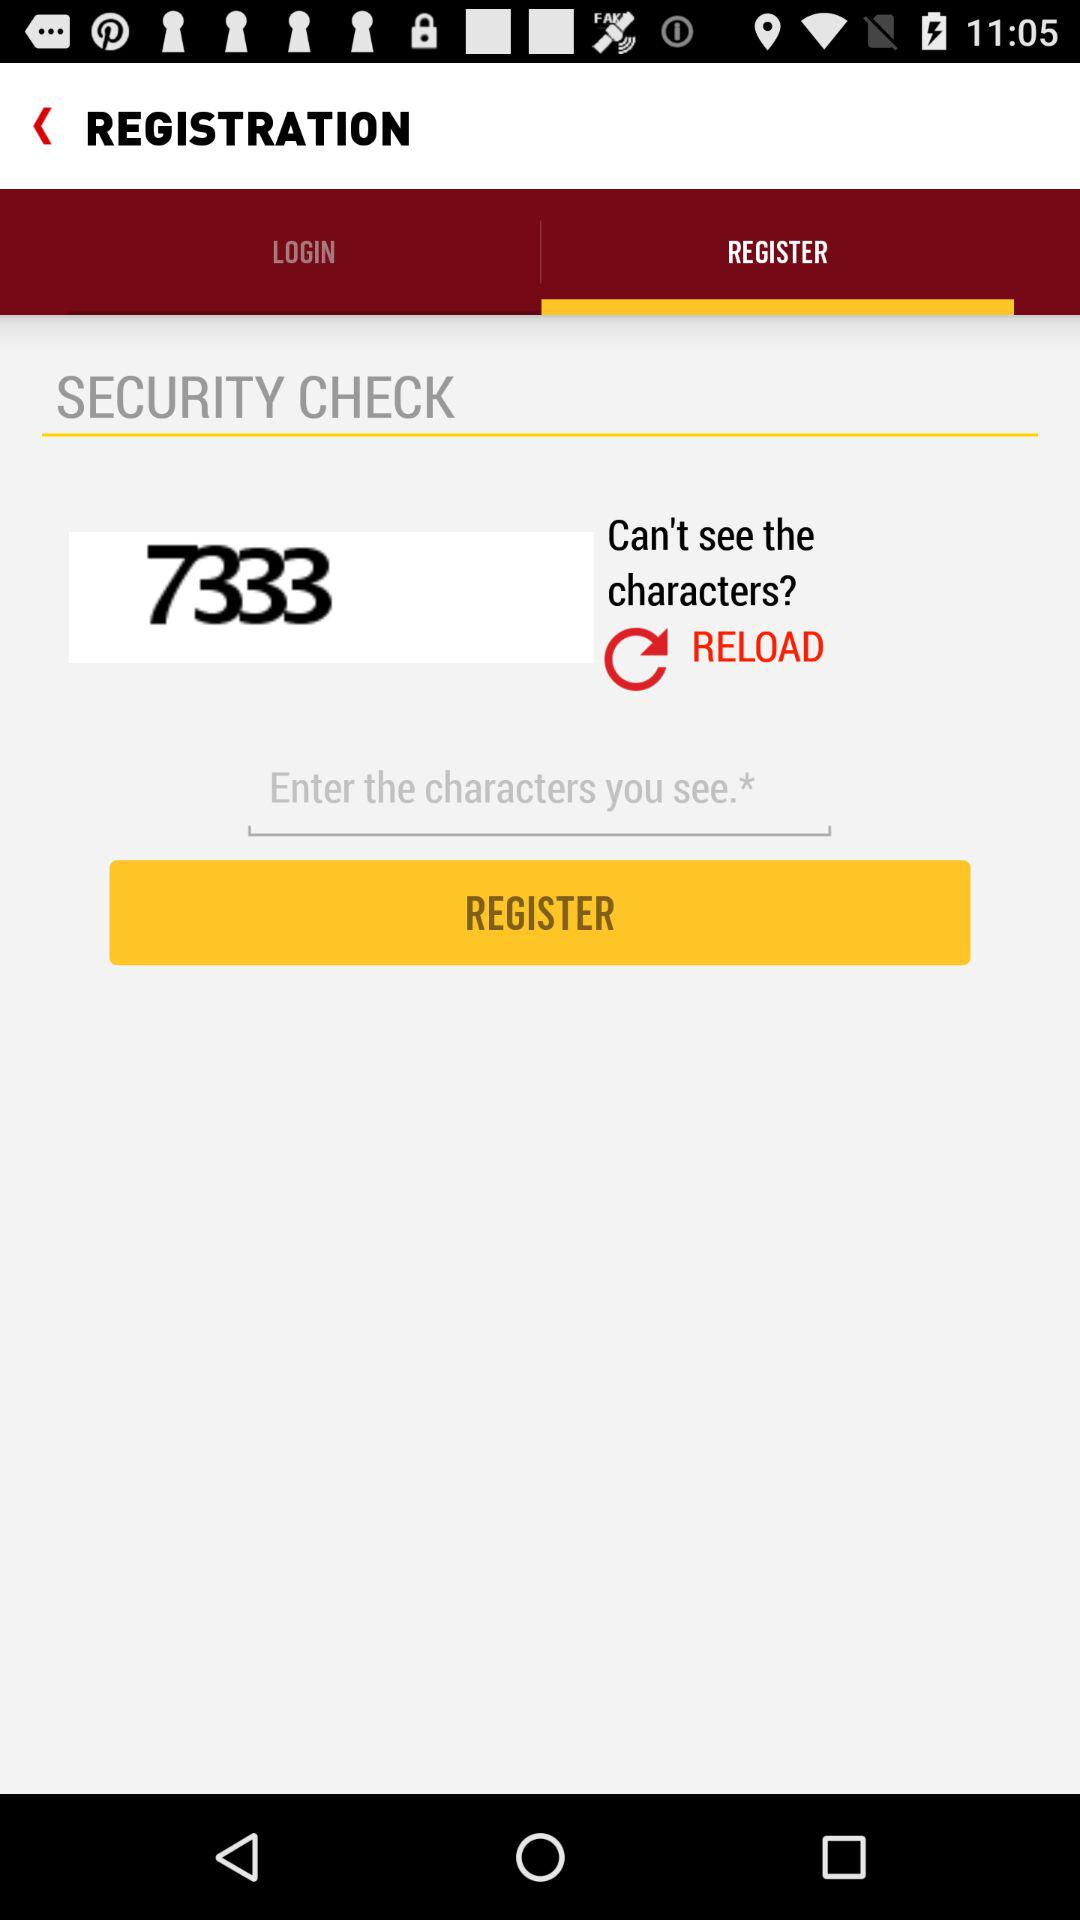Which tab is selected? The selected tab is "REGISTER". 